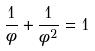<formula> <loc_0><loc_0><loc_500><loc_500>\frac { 1 } { \phi } + \frac { 1 } { \phi ^ { 2 } } = 1</formula> 